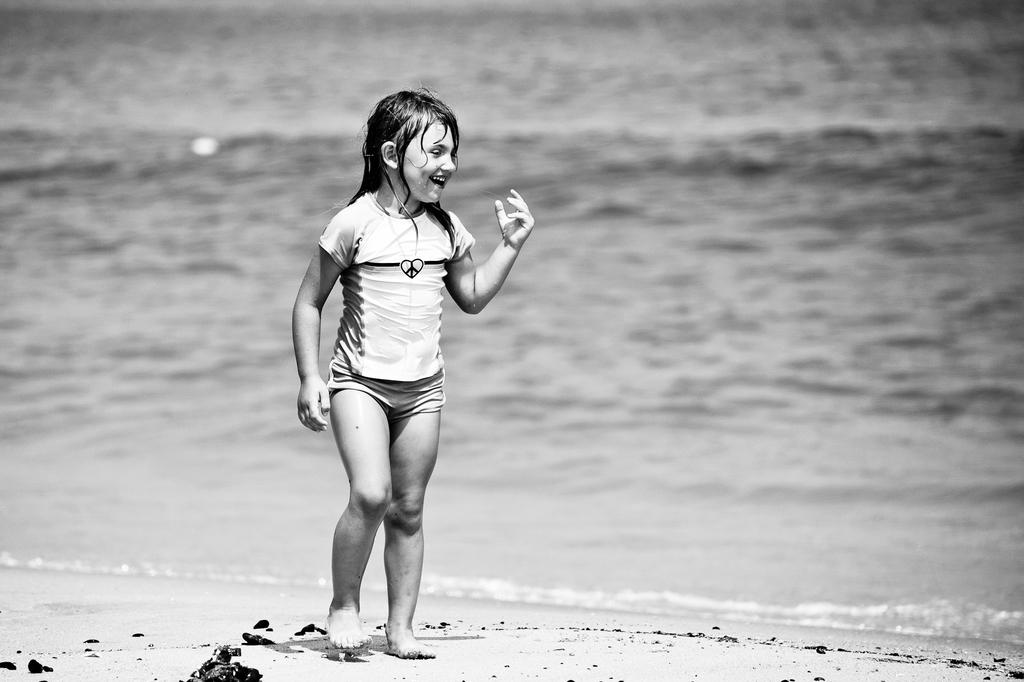Who is present in the image? There is a child in the image. Where is the child located? The child is at the beach. What is the child's expression in the image? The child is smiling. What can be seen in the background of the image? There is water visible in the image. What type of oven can be seen in the image? There is no oven present in the image; it is a child at the beach. How many pins are visible in the image? There are no pins present in the image. 